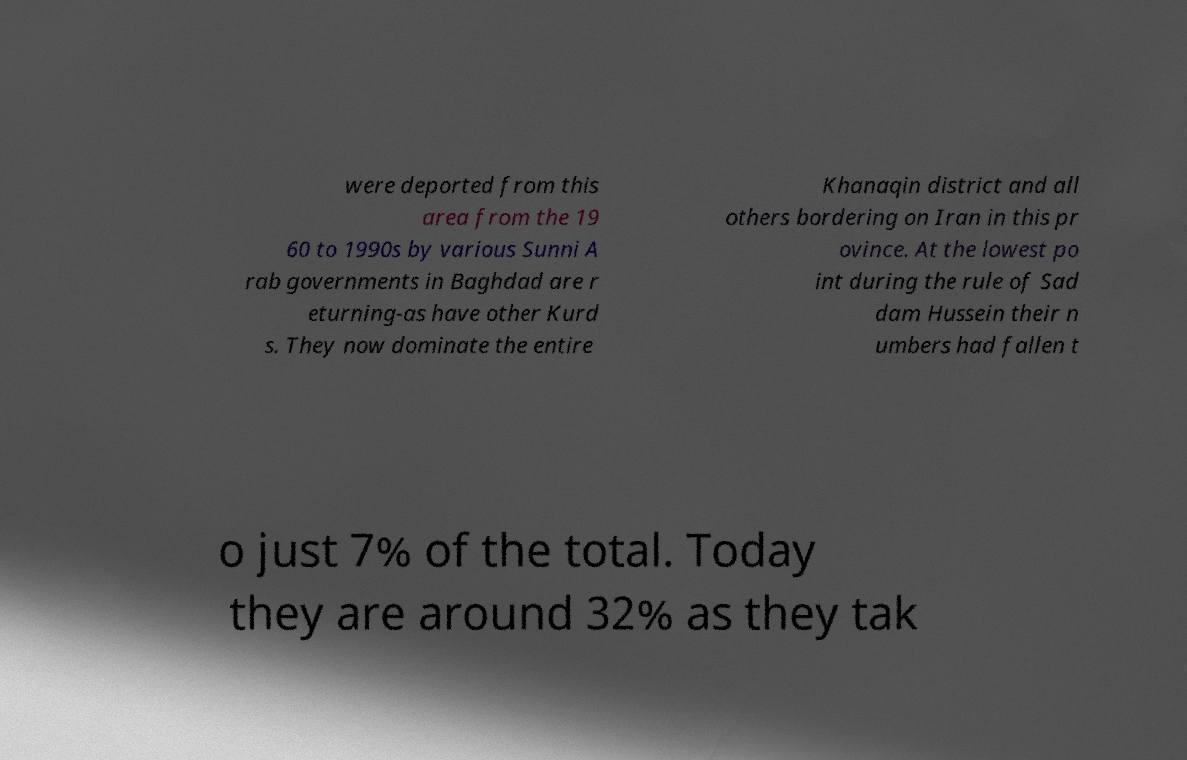I need the written content from this picture converted into text. Can you do that? were deported from this area from the 19 60 to 1990s by various Sunni A rab governments in Baghdad are r eturning-as have other Kurd s. They now dominate the entire Khanaqin district and all others bordering on Iran in this pr ovince. At the lowest po int during the rule of Sad dam Hussein their n umbers had fallen t o just 7% of the total. Today they are around 32% as they tak 